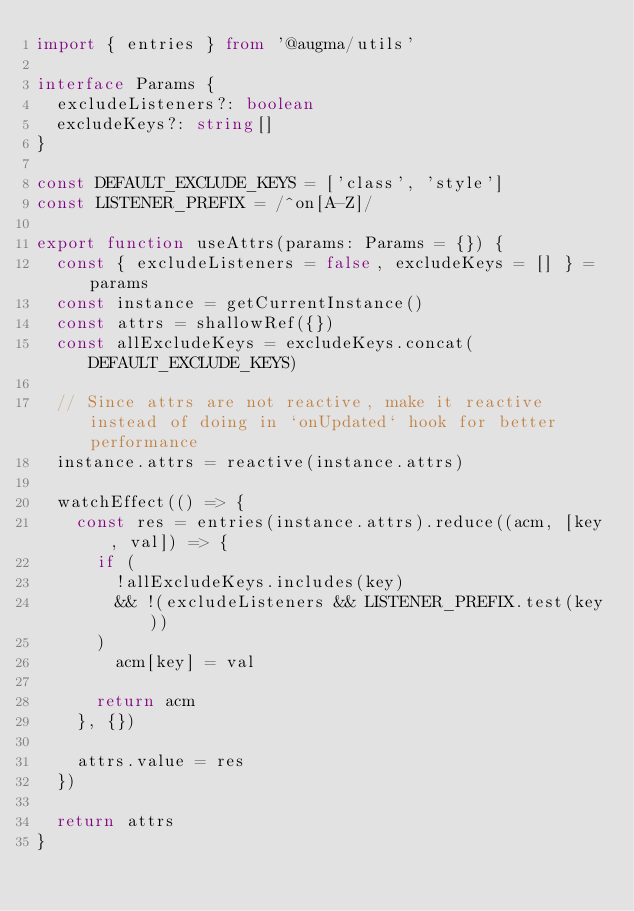<code> <loc_0><loc_0><loc_500><loc_500><_TypeScript_>import { entries } from '@augma/utils'

interface Params {
  excludeListeners?: boolean
  excludeKeys?: string[]
}

const DEFAULT_EXCLUDE_KEYS = ['class', 'style']
const LISTENER_PREFIX = /^on[A-Z]/

export function useAttrs(params: Params = {}) {
  const { excludeListeners = false, excludeKeys = [] } = params
  const instance = getCurrentInstance()
  const attrs = shallowRef({})
  const allExcludeKeys = excludeKeys.concat(DEFAULT_EXCLUDE_KEYS)

  // Since attrs are not reactive, make it reactive instead of doing in `onUpdated` hook for better performance
  instance.attrs = reactive(instance.attrs)

  watchEffect(() => {
    const res = entries(instance.attrs).reduce((acm, [key, val]) => {
      if (
        !allExcludeKeys.includes(key)
        && !(excludeListeners && LISTENER_PREFIX.test(key))
      )
        acm[key] = val

      return acm
    }, {})

    attrs.value = res
  })

  return attrs
}
</code> 